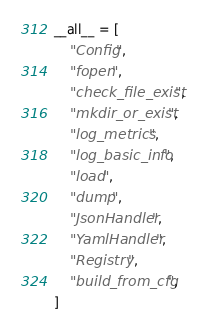<code> <loc_0><loc_0><loc_500><loc_500><_Python_>
__all__ = [
    "Config",
    "fopen",
    "check_file_exist",
    "mkdir_or_exist",
    "log_metrics",
    "log_basic_info",
    "load",
    "dump",
    "JsonHandler",
    "YamlHandler",
    "Registry",
    "build_from_cfg",
]
</code> 